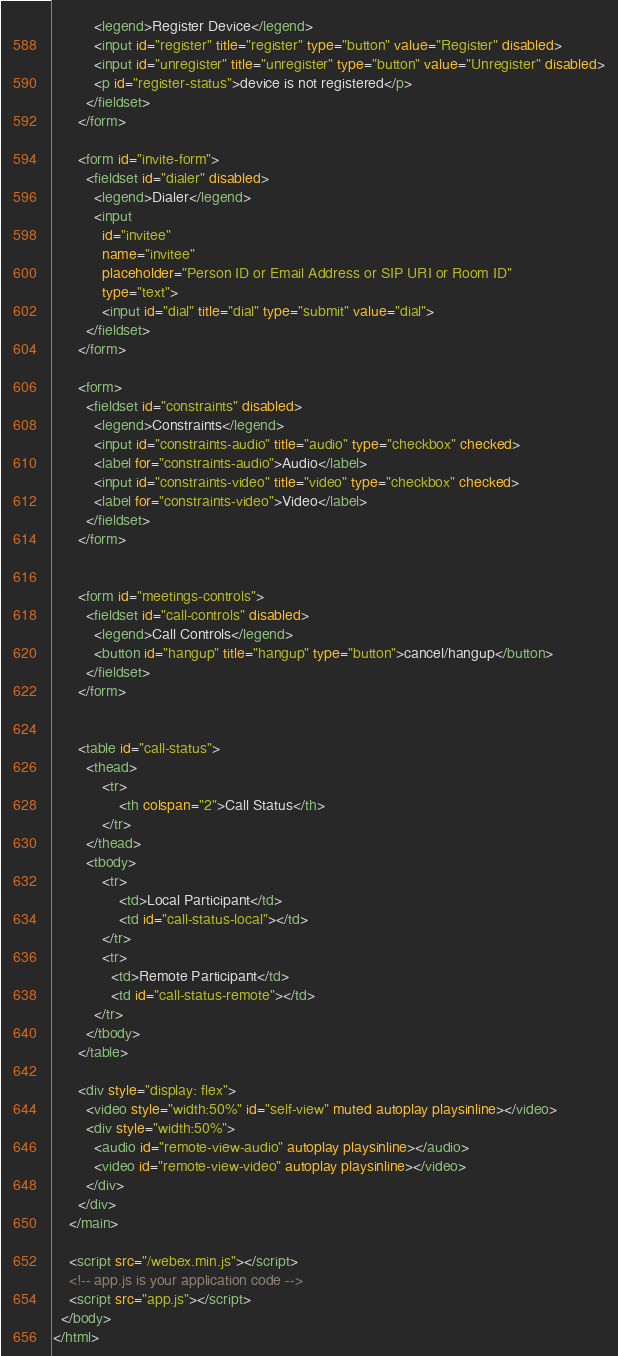Convert code to text. <code><loc_0><loc_0><loc_500><loc_500><_HTML_>          <legend>Register Device</legend>
          <input id="register" title="register" type="button" value="Register" disabled>
          <input id="unregister" title="unregister" type="button" value="Unregister" disabled>
          <p id="register-status">device is not registered</p>
        </fieldset>
      </form>

      <form id="invite-form">
        <fieldset id="dialer" disabled>
          <legend>Dialer</legend>
          <input
            id="invitee"
            name="invitee"
            placeholder="Person ID or Email Address or SIP URI or Room ID"
            type="text">
            <input id="dial" title="dial" type="submit" value="dial">
        </fieldset>
      </form>

      <form>
        <fieldset id="constraints" disabled>
          <legend>Constraints</legend>
          <input id="constraints-audio" title="audio" type="checkbox" checked>
          <label for="constraints-audio">Audio</label>
          <input id="constraints-video" title="video" type="checkbox" checked>
          <label for="constraints-video">Video</label>
        </fieldset>
      </form>


      <form id="meetings-controls">
        <fieldset id="call-controls" disabled>
          <legend>Call Controls</legend>
          <button id="hangup" title="hangup" type="button">cancel/hangup</button>
        </fieldset>
      </form>


      <table id="call-status">
        <thead>
            <tr>
                <th colspan="2">Call Status</th>
            </tr>
        </thead>
        <tbody>
            <tr>
                <td>Local Participant</td>
                <td id="call-status-local"></td>
            </tr>
            <tr>
              <td>Remote Participant</td>
              <td id="call-status-remote"></td>
          </tr>
        </tbody>
      </table>

      <div style="display: flex">
        <video style="width:50%" id="self-view" muted autoplay playsinline></video>
        <div style="width:50%">
          <audio id="remote-view-audio" autoplay playsinline></audio>
          <video id="remote-view-video" autoplay playsinline></video>
        </div>
      </div>
    </main>

    <script src="/webex.min.js"></script>
    <!-- app.js is your application code -->
    <script src="app.js"></script>
  </body>
</html>
</code> 